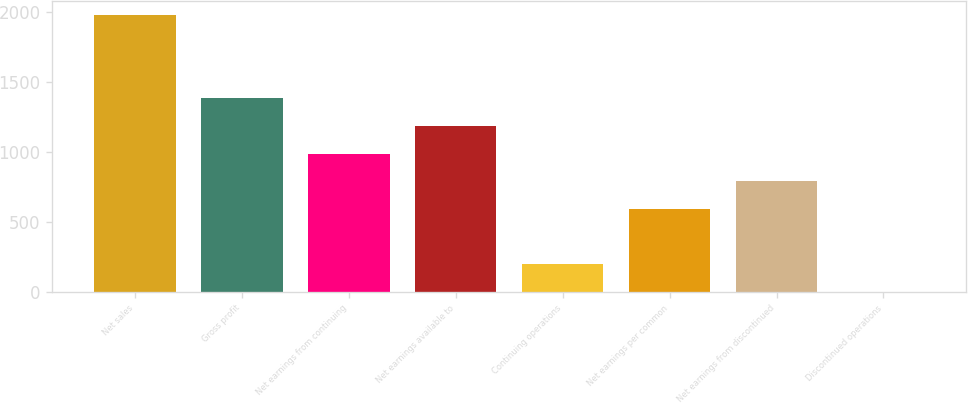Convert chart to OTSL. <chart><loc_0><loc_0><loc_500><loc_500><bar_chart><fcel>Net sales<fcel>Gross profit<fcel>Net earnings from continuing<fcel>Net earnings available to<fcel>Continuing operations<fcel>Net earnings per common<fcel>Net earnings from discontinued<fcel>Discontinued operations<nl><fcel>1973.6<fcel>1381.53<fcel>986.81<fcel>1184.17<fcel>197.37<fcel>592.09<fcel>789.45<fcel>0.01<nl></chart> 